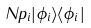<formula> <loc_0><loc_0><loc_500><loc_500>N p _ { i } | \phi _ { i } \rangle \langle \phi _ { i } |</formula> 